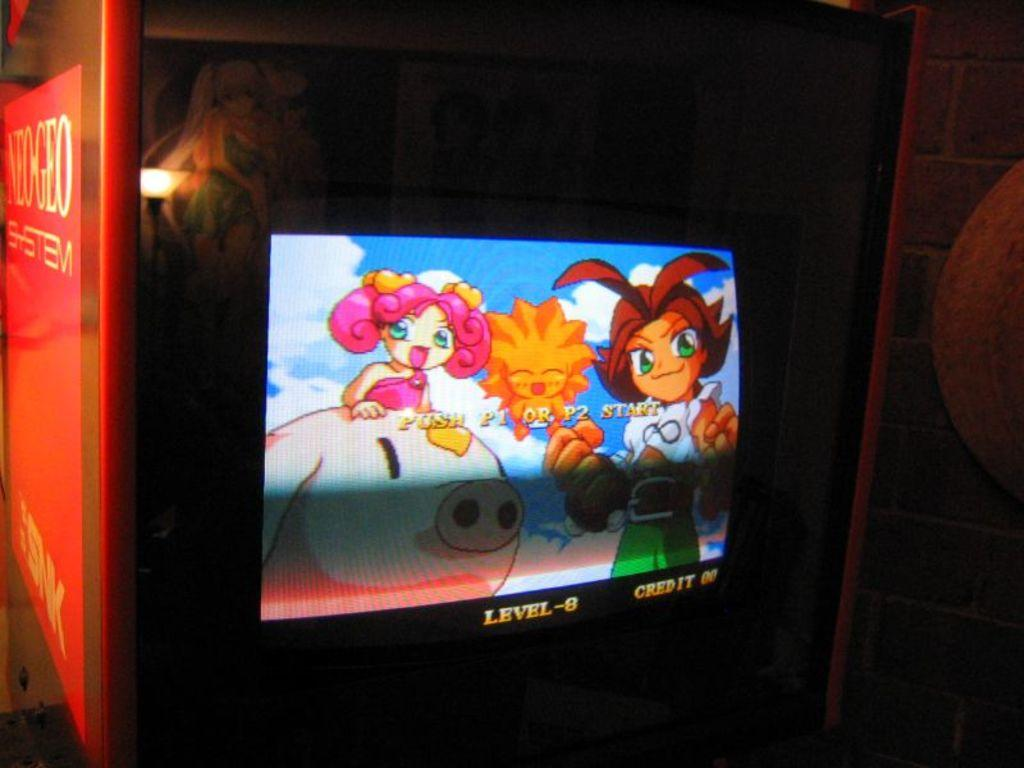Provide a one-sentence caption for the provided image. A video game is waiting for player 1 and player 2 to press start. 